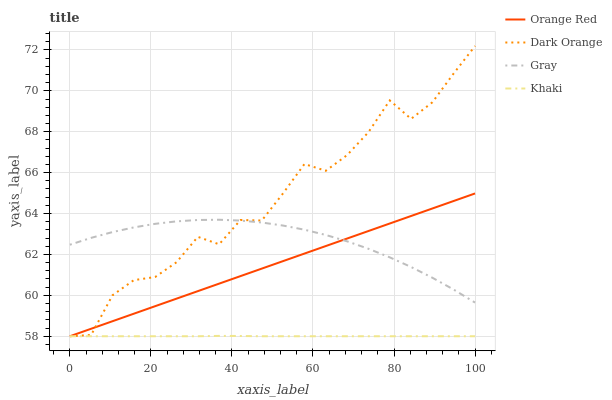Does Khaki have the minimum area under the curve?
Answer yes or no. Yes. Does Dark Orange have the maximum area under the curve?
Answer yes or no. Yes. Does Orange Red have the minimum area under the curve?
Answer yes or no. No. Does Orange Red have the maximum area under the curve?
Answer yes or no. No. Is Orange Red the smoothest?
Answer yes or no. Yes. Is Dark Orange the roughest?
Answer yes or no. Yes. Is Khaki the smoothest?
Answer yes or no. No. Is Khaki the roughest?
Answer yes or no. No. Does Dark Orange have the lowest value?
Answer yes or no. Yes. Does Gray have the lowest value?
Answer yes or no. No. Does Dark Orange have the highest value?
Answer yes or no. Yes. Does Orange Red have the highest value?
Answer yes or no. No. Is Khaki less than Gray?
Answer yes or no. Yes. Is Gray greater than Khaki?
Answer yes or no. Yes. Does Orange Red intersect Gray?
Answer yes or no. Yes. Is Orange Red less than Gray?
Answer yes or no. No. Is Orange Red greater than Gray?
Answer yes or no. No. Does Khaki intersect Gray?
Answer yes or no. No. 